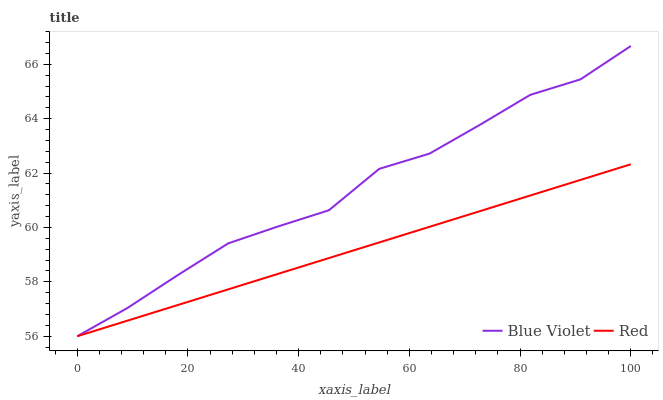Does Red have the minimum area under the curve?
Answer yes or no. Yes. Does Blue Violet have the maximum area under the curve?
Answer yes or no. Yes. Does Blue Violet have the minimum area under the curve?
Answer yes or no. No. Is Red the smoothest?
Answer yes or no. Yes. Is Blue Violet the roughest?
Answer yes or no. Yes. Is Blue Violet the smoothest?
Answer yes or no. No. Does Red have the lowest value?
Answer yes or no. Yes. Does Blue Violet have the highest value?
Answer yes or no. Yes. Does Red intersect Blue Violet?
Answer yes or no. Yes. Is Red less than Blue Violet?
Answer yes or no. No. Is Red greater than Blue Violet?
Answer yes or no. No. 